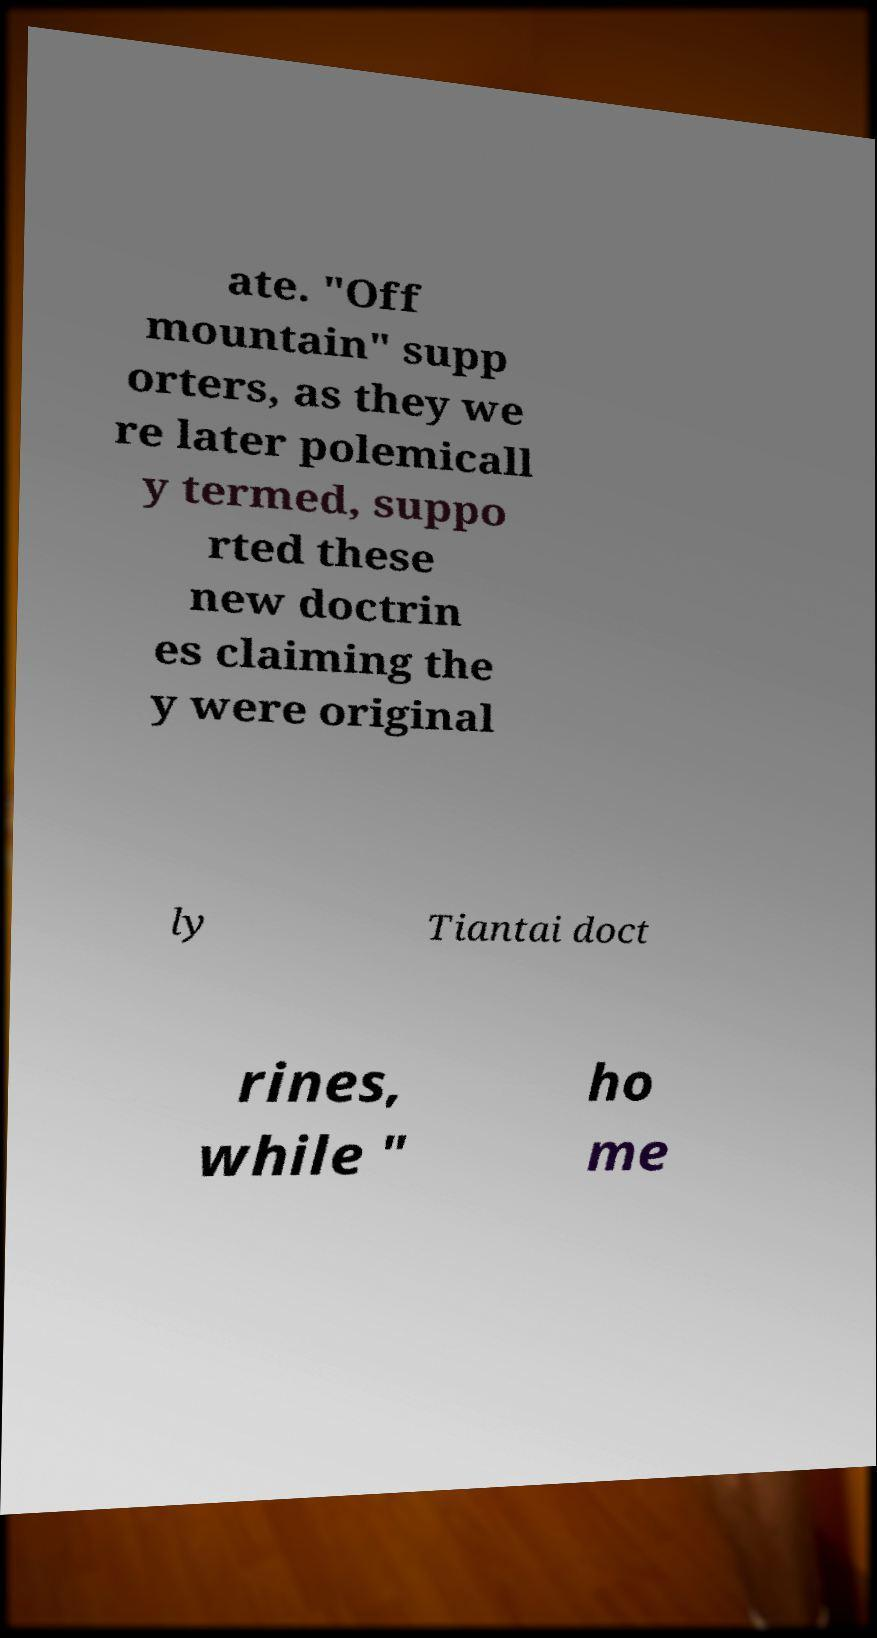Please read and relay the text visible in this image. What does it say? ate. "Off mountain" supp orters, as they we re later polemicall y termed, suppo rted these new doctrin es claiming the y were original ly Tiantai doct rines, while " ho me 